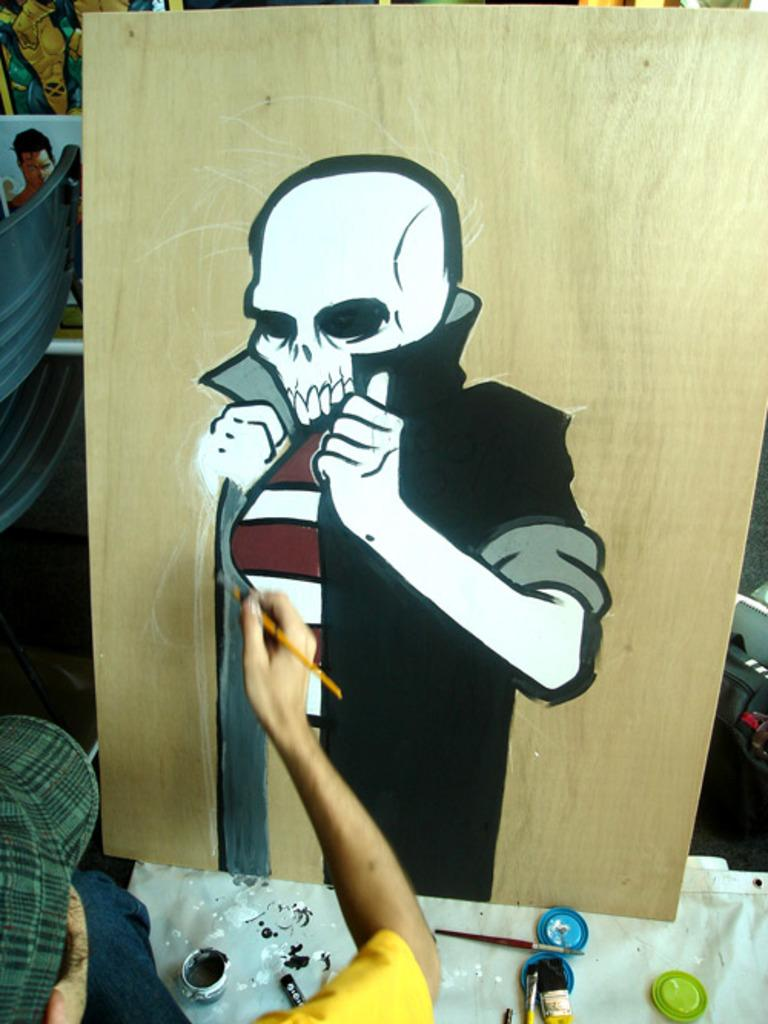What is the person in the image doing? The person in the image is painting a picture. What is the subject of the picture being painted? The picture being painted is of a skeleton. On what surface is the person painting the picture? The picture is being painted on a wooden board. What items are in front of the person that might be used for painting? There are containers and brushes in front of the person. What type of boundary can be seen in the image? There is no boundary present in the image. How many sheep are visible in the image? There are no sheep present in the image. 